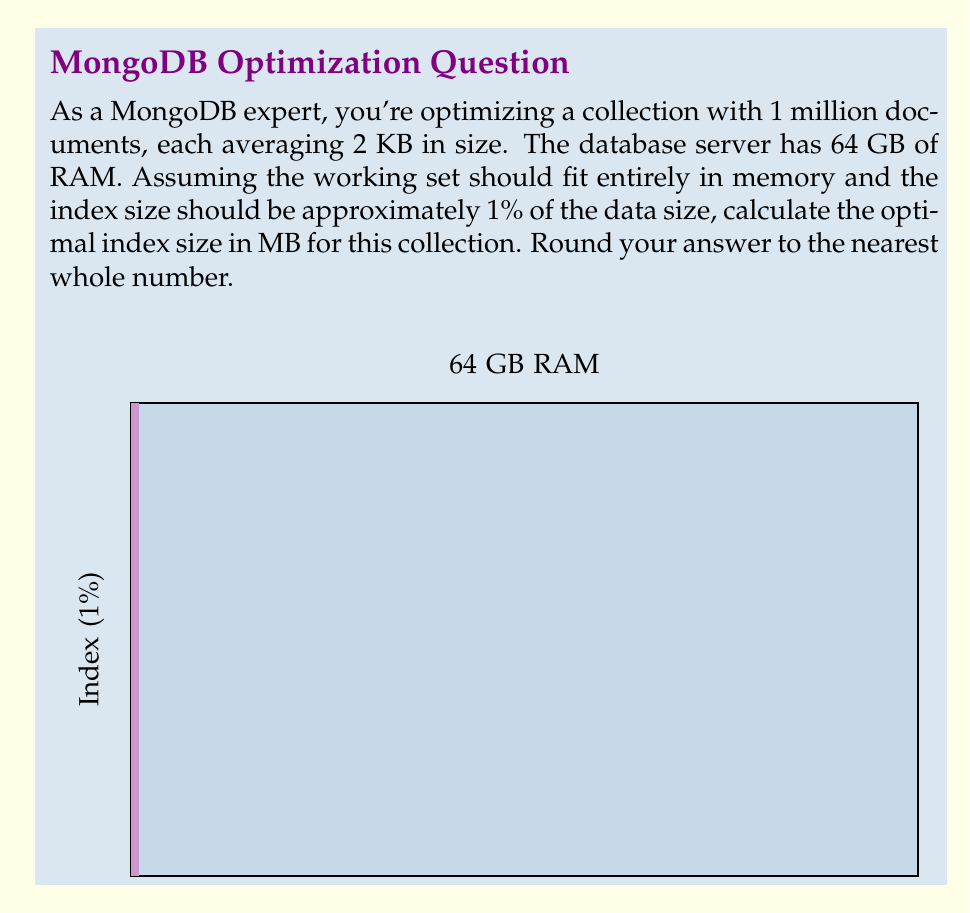Can you answer this question? Let's approach this step-by-step:

1) First, calculate the total size of the collection:
   $$\text{Total size} = 1,000,000 \text{ documents} \times 2 \text{ KB} = 2,000,000 \text{ KB} = 2,000 \text{ MB} = 2 \text{ GB}$$

2) The index size should be approximately 1% of the data size:
   $$\text{Index size} = 1\% \times 2 \text{ GB} = 0.02 \text{ GB} = 20 \text{ MB}$$

3) To verify if this fits within the memory constraints:
   - Total data size: 2 GB
   - Index size: 0.02 GB
   - Total: 2.02 GB

   This is well within the 64 GB of available RAM, so our calculation is valid.

4) Round the result to the nearest whole number:
   20 MB requires no rounding.

Therefore, the optimal index size for this collection is 20 MB.
Answer: 20 MB 